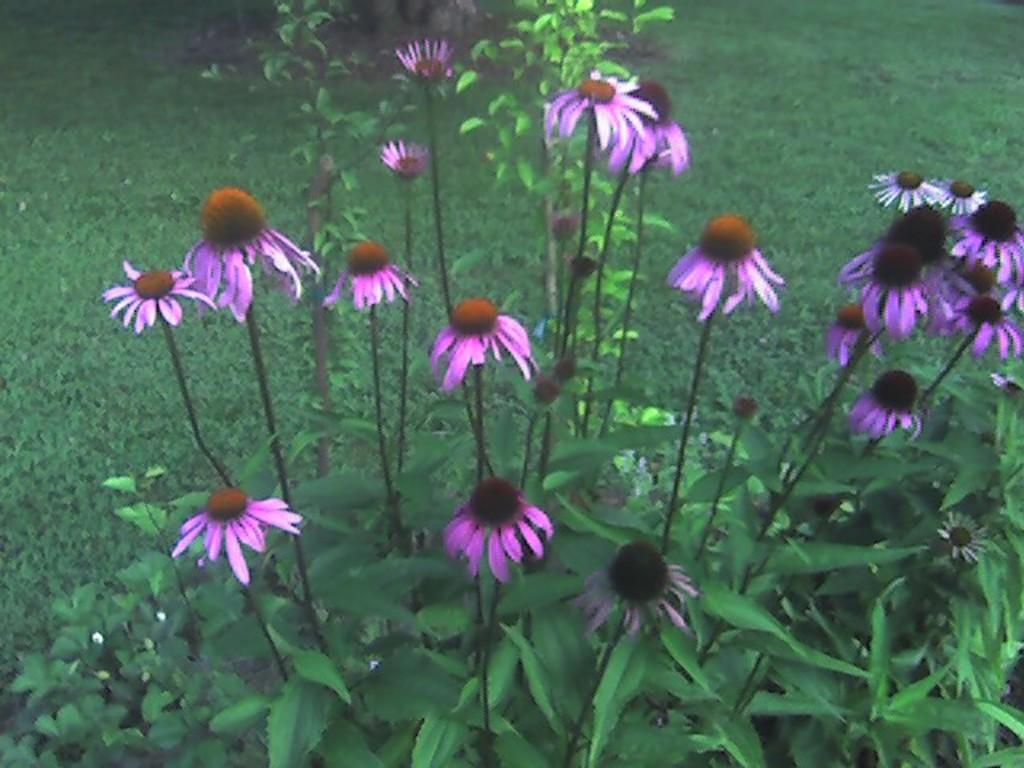What type of living organisms can be seen in the image? Plants and flowers are visible in the image. What is the color of the flowers in the image? The flowers in the image are pink. Where are the flowers located in relation to the plants? The flowers are in front of the plants. What can be seen in the background of the image? Grass is visible in the background of the image. Are there any worms crawling on the frame of the image? There is no frame present in the image, and therefore no worms can be seen on it. 